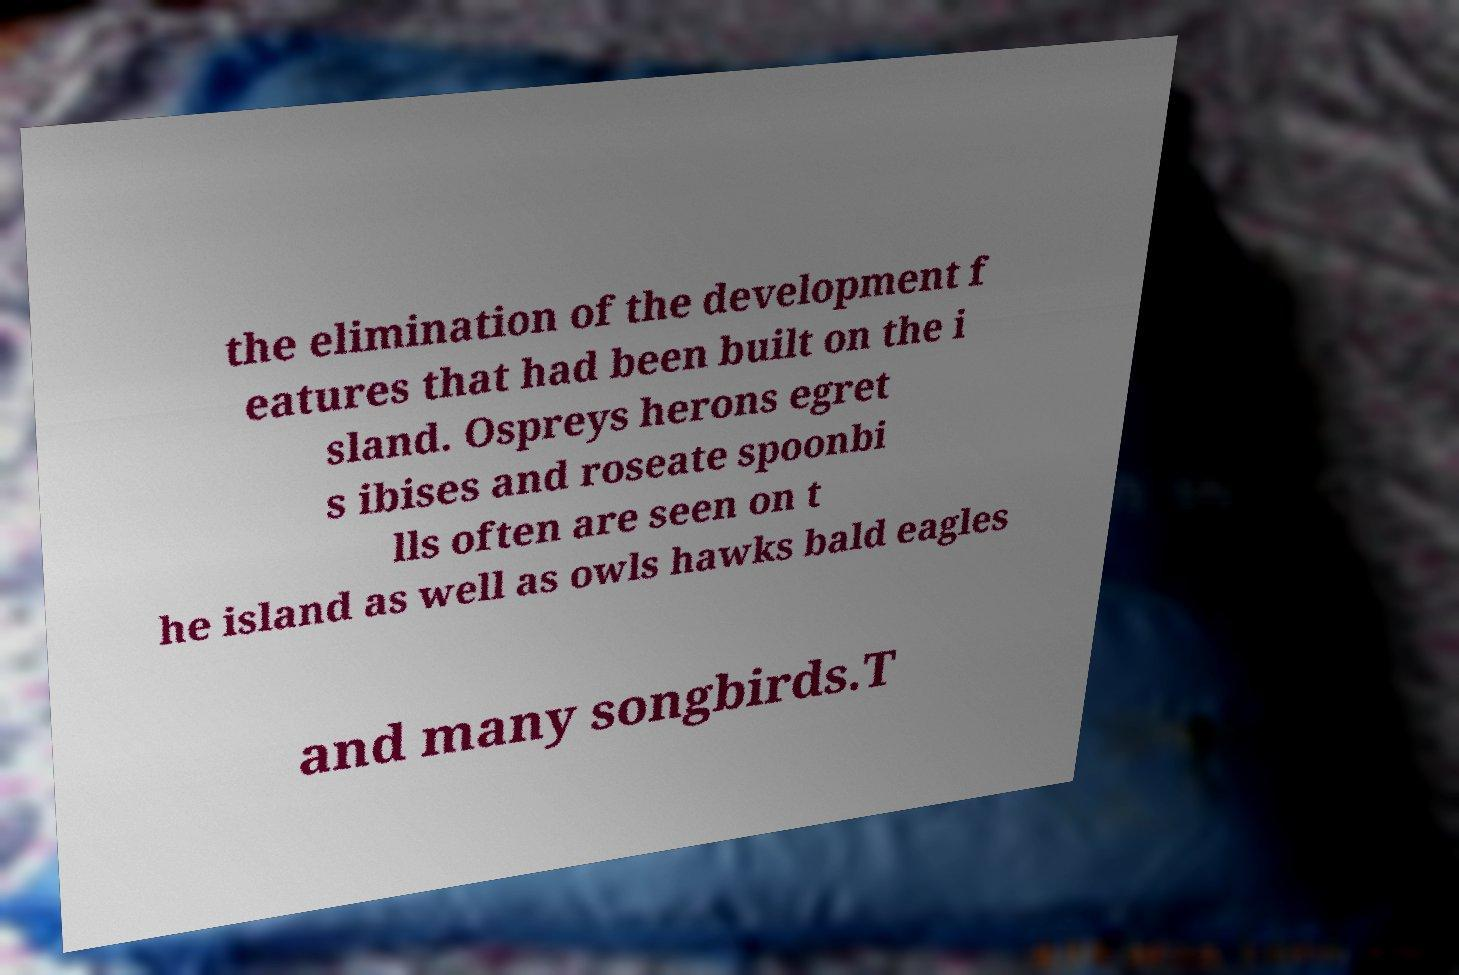Can you accurately transcribe the text from the provided image for me? the elimination of the development f eatures that had been built on the i sland. Ospreys herons egret s ibises and roseate spoonbi lls often are seen on t he island as well as owls hawks bald eagles and many songbirds.T 